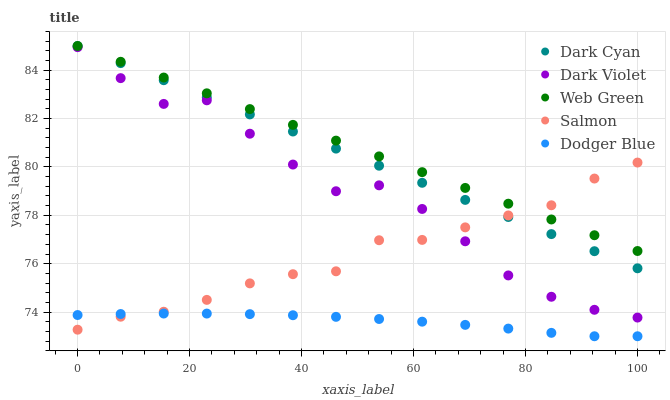Does Dodger Blue have the minimum area under the curve?
Answer yes or no. Yes. Does Web Green have the maximum area under the curve?
Answer yes or no. Yes. Does Salmon have the minimum area under the curve?
Answer yes or no. No. Does Salmon have the maximum area under the curve?
Answer yes or no. No. Is Web Green the smoothest?
Answer yes or no. Yes. Is Dark Violet the roughest?
Answer yes or no. Yes. Is Dodger Blue the smoothest?
Answer yes or no. No. Is Dodger Blue the roughest?
Answer yes or no. No. Does Dodger Blue have the lowest value?
Answer yes or no. Yes. Does Salmon have the lowest value?
Answer yes or no. No. Does Web Green have the highest value?
Answer yes or no. Yes. Does Salmon have the highest value?
Answer yes or no. No. Is Dark Violet less than Web Green?
Answer yes or no. Yes. Is Dark Cyan greater than Dark Violet?
Answer yes or no. Yes. Does Web Green intersect Salmon?
Answer yes or no. Yes. Is Web Green less than Salmon?
Answer yes or no. No. Is Web Green greater than Salmon?
Answer yes or no. No. Does Dark Violet intersect Web Green?
Answer yes or no. No. 